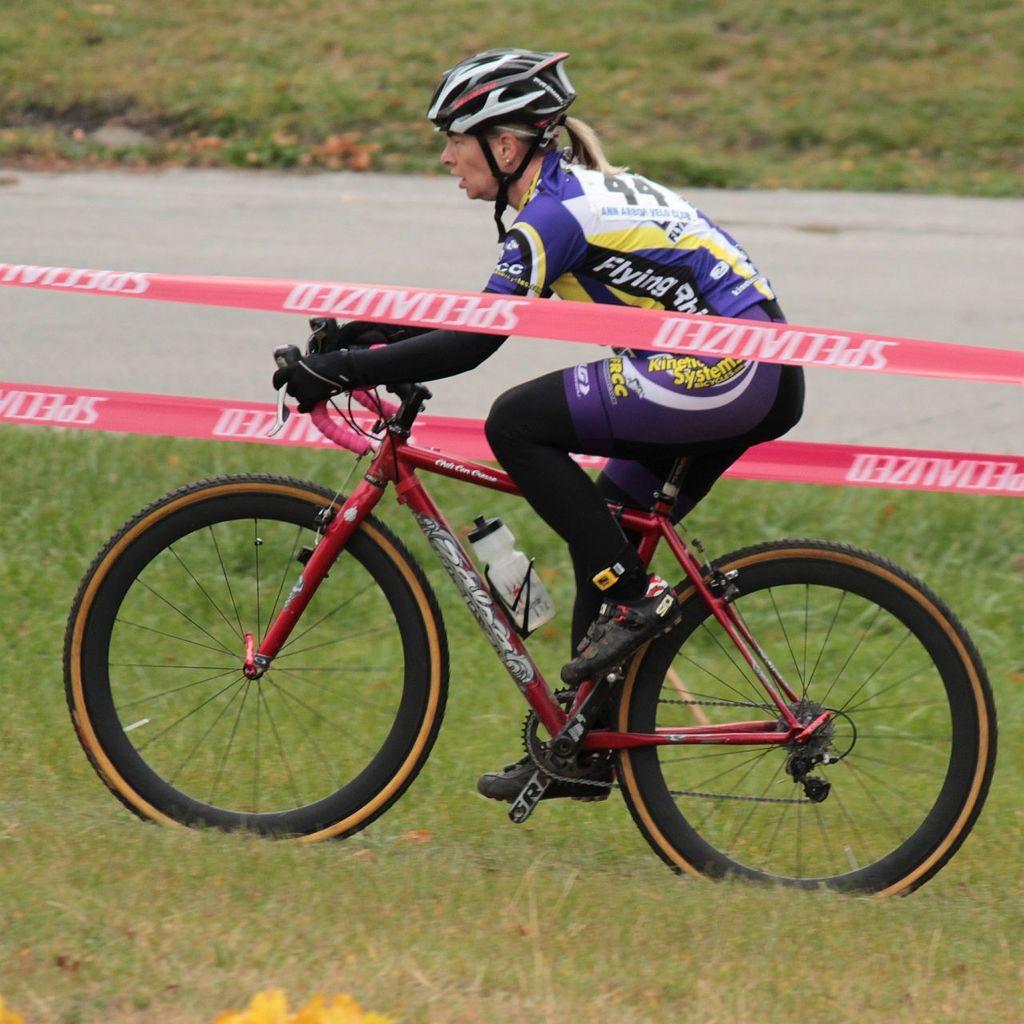Describe this image in one or two sentences. In this picture we can observe a person cycling a bicycle. We can observe red color ribbons on either sides of the red color bicycle. We can observe a person is wearing helmet on their head. There is some grass on the ground. 